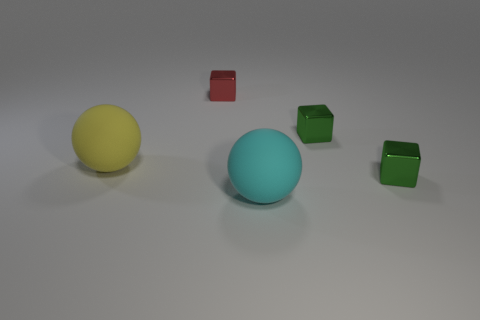Subtract all green shiny cubes. How many cubes are left? 1 Subtract all red blocks. How many blocks are left? 2 Subtract 3 blocks. How many blocks are left? 0 Subtract all spheres. How many objects are left? 3 Subtract all green blocks. Subtract all blue cylinders. How many blocks are left? 1 Subtract 0 red cylinders. How many objects are left? 5 Subtract all cyan balls. How many green cubes are left? 2 Subtract all blocks. Subtract all small gray shiny cylinders. How many objects are left? 2 Add 1 red metal cubes. How many red metal cubes are left? 2 Add 5 cyan things. How many cyan things exist? 6 